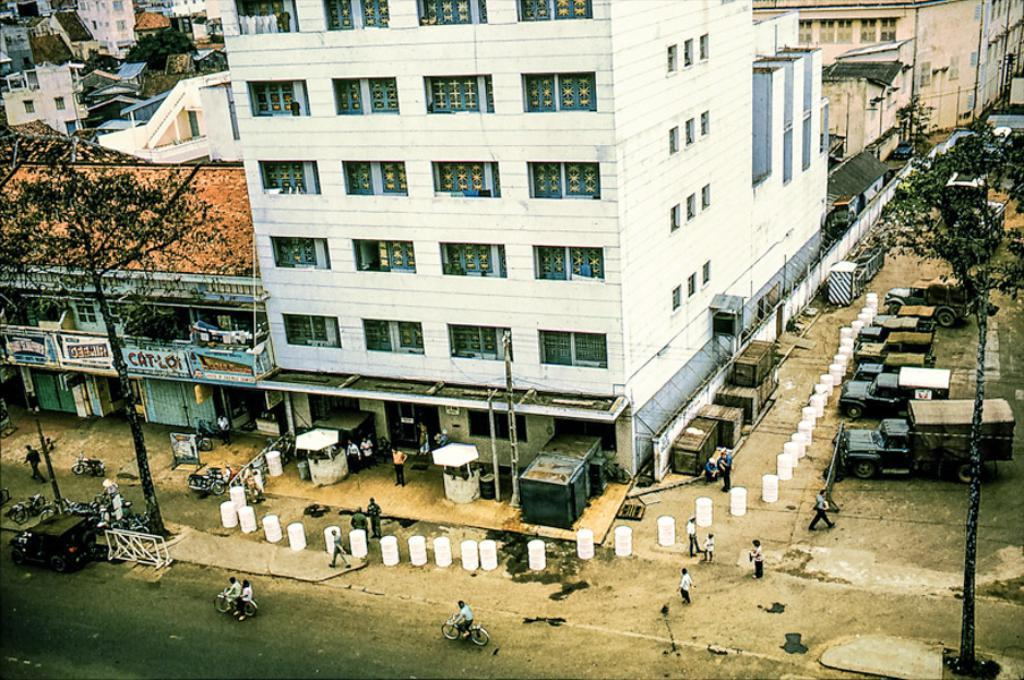What is the main feature of the image? There is a road in the image. What is happening on the road? There are vehicles on the road. Are there any people present in the image? Yes, there are people standing in the image. What can be seen near the road? There are white-colored poles in the image. What else is visible in the image? There are trees and buildings in the image. What type of voice can be heard coming from the brass instrument in the image? There is no brass instrument present in the image, so it is not possible to determine what type of voice might be heard. 